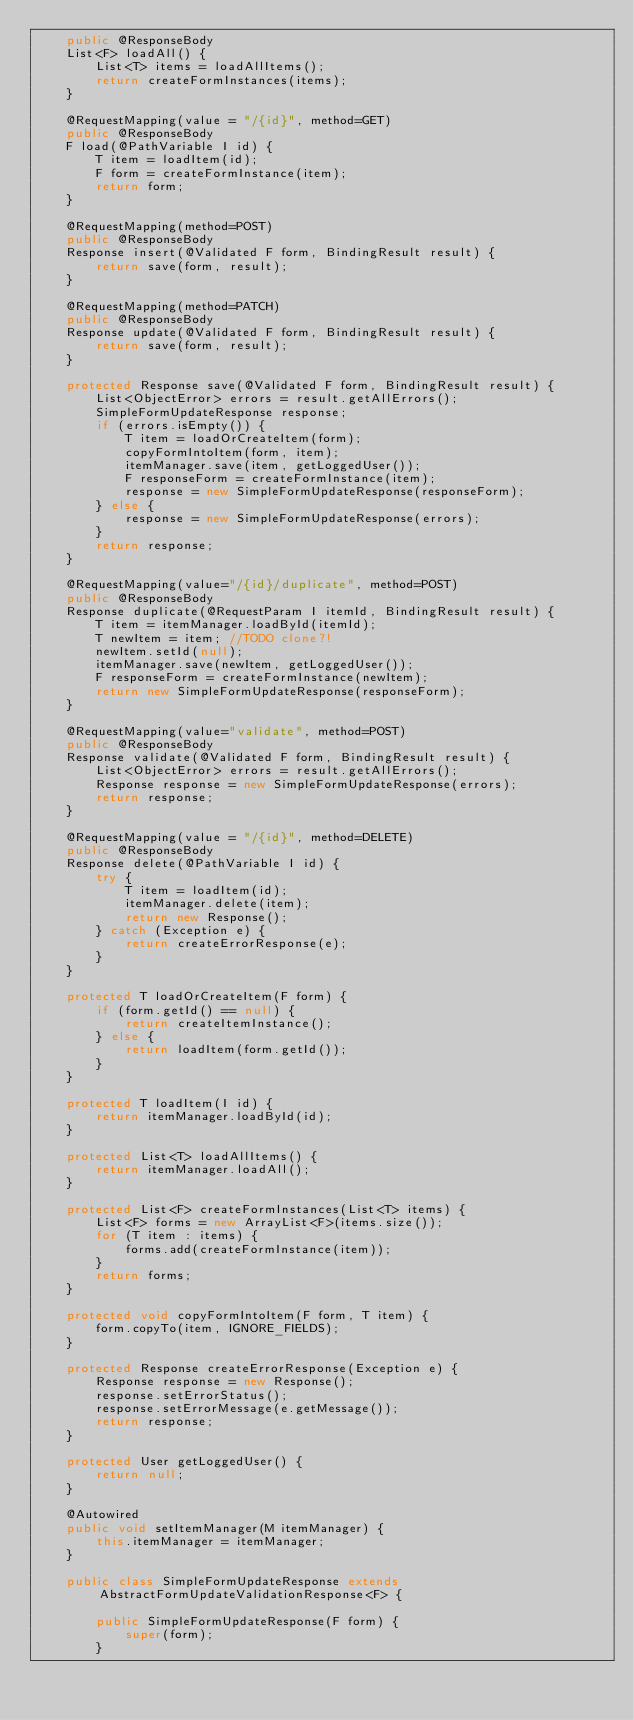Convert code to text. <code><loc_0><loc_0><loc_500><loc_500><_Java_>	public @ResponseBody
	List<F> loadAll() {
		List<T> items = loadAllItems();
		return createFormInstances(items);
	}
	
	@RequestMapping(value = "/{id}", method=GET)
	public @ResponseBody
	F load(@PathVariable I id) {
		T item = loadItem(id);
		F form = createFormInstance(item);
		return form;
	}
	
	@RequestMapping(method=POST)
	public @ResponseBody
	Response insert(@Validated F form, BindingResult result) {
		return save(form, result);
	}
	
	@RequestMapping(method=PATCH)
	public @ResponseBody
	Response update(@Validated F form, BindingResult result) {
		return save(form, result);
	}
	
	protected Response save(@Validated F form, BindingResult result) {
		List<ObjectError> errors = result.getAllErrors();
		SimpleFormUpdateResponse response;
		if (errors.isEmpty()) {
			T item = loadOrCreateItem(form);
			copyFormIntoItem(form, item);
			itemManager.save(item, getLoggedUser());
			F responseForm = createFormInstance(item);
			response = new SimpleFormUpdateResponse(responseForm);
		} else {
			response = new SimpleFormUpdateResponse(errors);
		}
		return response;
	}
	
	@RequestMapping(value="/{id}/duplicate", method=POST)
	public @ResponseBody
	Response duplicate(@RequestParam I itemId, BindingResult result) {
		T item = itemManager.loadById(itemId);
		T newItem = item; //TODO clone?!
		newItem.setId(null);
		itemManager.save(newItem, getLoggedUser());
		F responseForm = createFormInstance(newItem);
		return new SimpleFormUpdateResponse(responseForm);
	}
	
	@RequestMapping(value="validate", method=POST)
	public @ResponseBody
	Response validate(@Validated F form, BindingResult result) {
		List<ObjectError> errors = result.getAllErrors();
		Response response = new SimpleFormUpdateResponse(errors);
		return response;
	}
	
	@RequestMapping(value = "/{id}", method=DELETE)
	public @ResponseBody
	Response delete(@PathVariable I id) {
		try {
			T item = loadItem(id);
			itemManager.delete(item);
			return new Response();
		} catch (Exception e) {
			return createErrorResponse(e);
		}
	}
	
	protected T loadOrCreateItem(F form) {
		if (form.getId() == null) {
			return createItemInstance();
		} else {
			return loadItem(form.getId());
		}
	}

	protected T loadItem(I id) {
		return itemManager.loadById(id);
	}
	
	protected List<T> loadAllItems() {
		return itemManager.loadAll();
	}
	
	protected List<F> createFormInstances(List<T> items) {
		List<F> forms = new ArrayList<F>(items.size());
		for (T item : items) {
			forms.add(createFormInstance(item));
		}
		return forms;
	}

	protected void copyFormIntoItem(F form, T item) {
		form.copyTo(item, IGNORE_FIELDS);
	}
	
	protected Response createErrorResponse(Exception e) {
		Response response = new Response();
		response.setErrorStatus();
		response.setErrorMessage(e.getMessage());
		return response;
	}
	
	protected User getLoggedUser() {
		return null;
	}
	
	@Autowired
	public void setItemManager(M itemManager) {
		this.itemManager = itemManager;
	}

	public class SimpleFormUpdateResponse extends AbstractFormUpdateValidationResponse<F> {

		public SimpleFormUpdateResponse(F form) {
			super(form);
		}
</code> 